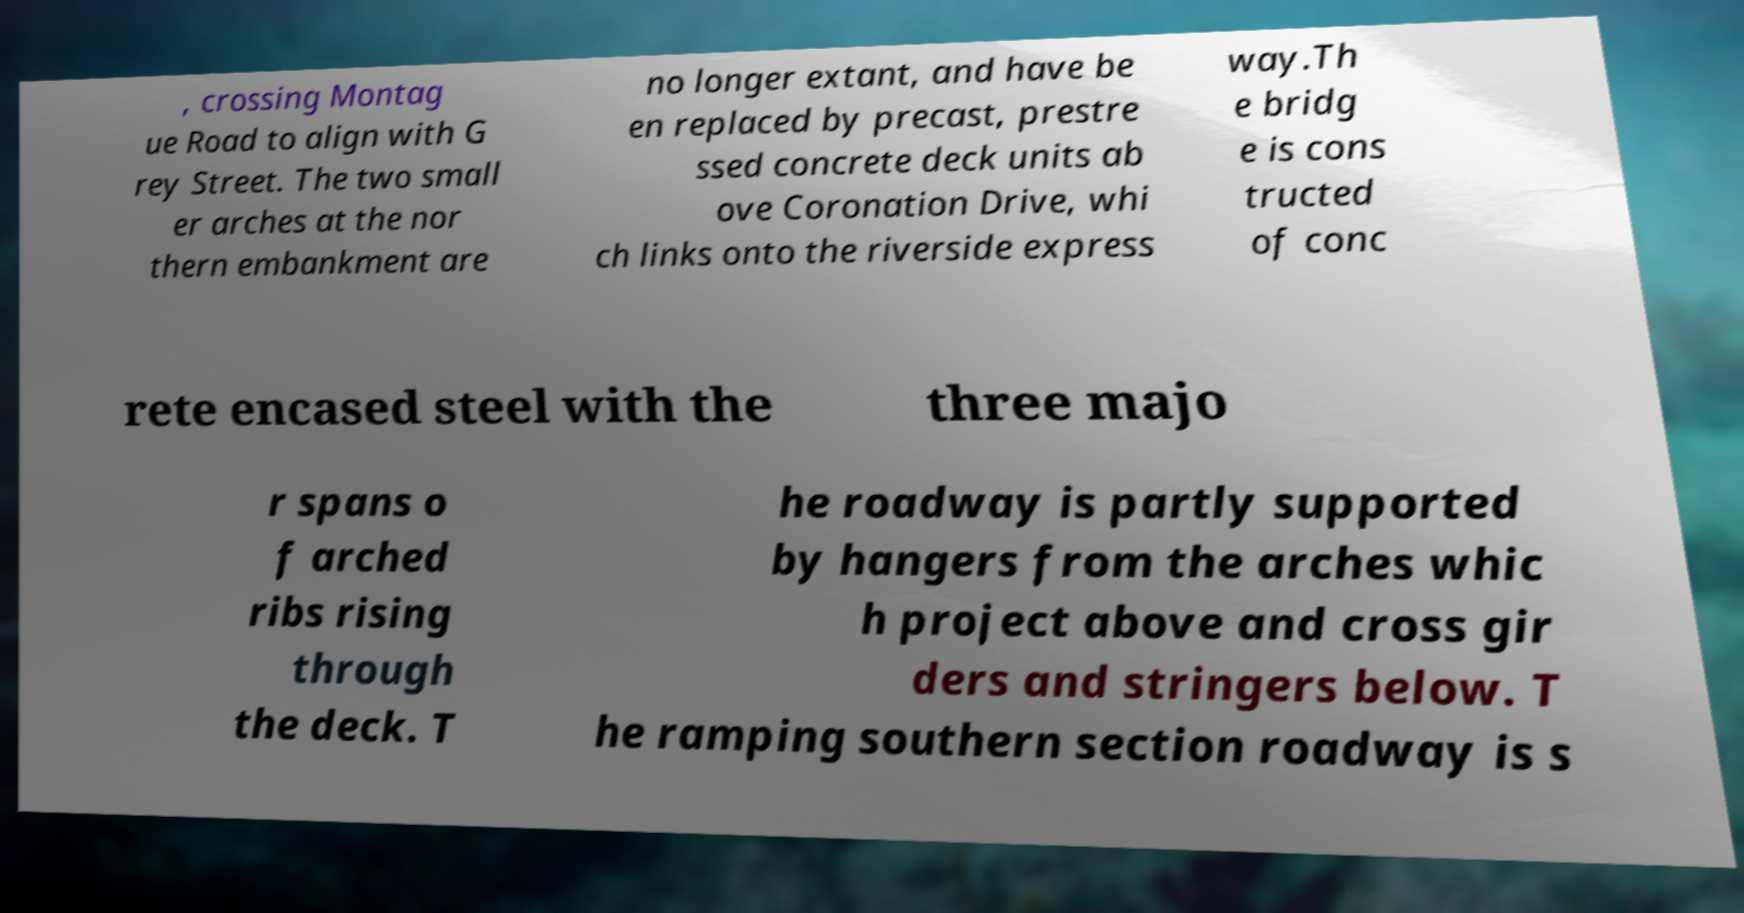I need the written content from this picture converted into text. Can you do that? , crossing Montag ue Road to align with G rey Street. The two small er arches at the nor thern embankment are no longer extant, and have be en replaced by precast, prestre ssed concrete deck units ab ove Coronation Drive, whi ch links onto the riverside express way.Th e bridg e is cons tructed of conc rete encased steel with the three majo r spans o f arched ribs rising through the deck. T he roadway is partly supported by hangers from the arches whic h project above and cross gir ders and stringers below. T he ramping southern section roadway is s 